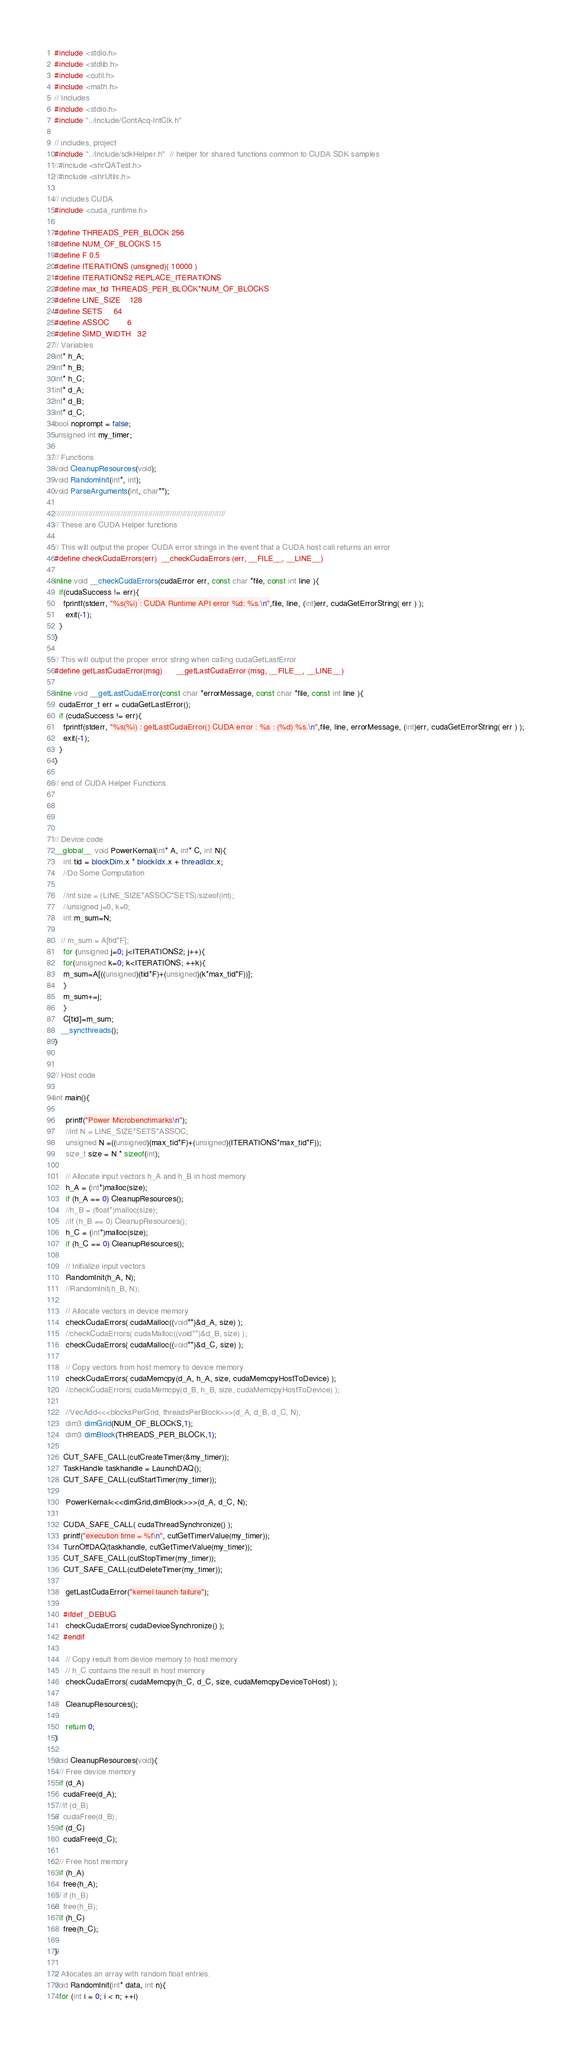Convert code to text. <code><loc_0><loc_0><loc_500><loc_500><_Cuda_>#include <stdio.h>
#include <stdlib.h>
#include <cutil.h>
#include <math.h>
// Includes
#include <stdio.h>
#include "../include/ContAcq-IntClk.h"

// includes, project
#include "../include/sdkHelper.h"  // helper for shared functions common to CUDA SDK samples
//#include <shrQATest.h>
//#include <shrUtils.h>

// includes CUDA
#include <cuda_runtime.h>

#define THREADS_PER_BLOCK 256
#define NUM_OF_BLOCKS 15
#define F 0.5
#define ITERATIONS (unsigned)( 10000 )
#define ITERATIONS2 REPLACE_ITERATIONS
#define max_tid THREADS_PER_BLOCK*NUM_OF_BLOCKS
#define LINE_SIZE 	128
#define SETS		64
#define ASSOC		6
#define SIMD_WIDTH	32
// Variables
int* h_A;
int* h_B;
int* h_C;
int* d_A;
int* d_B;
int* d_C;
bool noprompt = false;
unsigned int my_timer;

// Functions
void CleanupResources(void);
void RandomInit(int*, int);
void ParseArguments(int, char**);

////////////////////////////////////////////////////////////////////////////////
// These are CUDA Helper functions

// This will output the proper CUDA error strings in the event that a CUDA host call returns an error
#define checkCudaErrors(err)  __checkCudaErrors (err, __FILE__, __LINE__)

inline void __checkCudaErrors(cudaError err, const char *file, const int line ){
  if(cudaSuccess != err){
	fprintf(stderr, "%s(%i) : CUDA Runtime API error %d: %s.\n",file, line, (int)err, cudaGetErrorString( err ) );
	 exit(-1);
  }
}

// This will output the proper error string when calling cudaGetLastError
#define getLastCudaError(msg)      __getLastCudaError (msg, __FILE__, __LINE__)

inline void __getLastCudaError(const char *errorMessage, const char *file, const int line ){
  cudaError_t err = cudaGetLastError();
  if (cudaSuccess != err){
	fprintf(stderr, "%s(%i) : getLastCudaError() CUDA error : %s : (%d) %s.\n",file, line, errorMessage, (int)err, cudaGetErrorString( err ) );
	exit(-1);
  }
}

// end of CUDA Helper Functions




// Device code
__global__ void PowerKernal(int* A, int* C, int N){
    int tid = blockDim.x * blockIdx.x + threadIdx.x;
    //Do Some Computation

    //int size = (LINE_SIZE*ASSOC*SETS)/sizeof(int);
    //unsigned j=0, k=0;
    int m_sum=N;

   // m_sum = A[tid*F];
    for (unsigned j=0; j<ITERATIONS2; j++){
    for(unsigned k=0; k<ITERATIONS; ++k){
	m_sum=A[((unsigned)(tid*F)+(unsigned)(k*max_tid*F))];
    }
    m_sum+=j;
    }
    C[tid]=m_sum;
   __syncthreads();
}


// Host code

int main(){

	 printf("Power Microbenchmarks\n");
	 //int N = LINE_SIZE*SETS*ASSOC;
	 unsigned N =((unsigned)(max_tid*F)+(unsigned)(ITERATIONS*max_tid*F));
	 size_t size = N * sizeof(int);

	 // Allocate input vectors h_A and h_B in host memory
	 h_A = (int*)malloc(size);
	 if (h_A == 0) CleanupResources();
	 //h_B = (float*)malloc(size);
	 //if (h_B == 0) CleanupResources();
	 h_C = (int*)malloc(size);
	 if (h_C == 0) CleanupResources();

	 // Initialize input vectors
	 RandomInit(h_A, N);
	 //RandomInit(h_B, N);

	 // Allocate vectors in device memory
	 checkCudaErrors( cudaMalloc((void**)&d_A, size) );
	 //checkCudaErrors( cudaMalloc((void**)&d_B, size) );
	 checkCudaErrors( cudaMalloc((void**)&d_C, size) );

	 // Copy vectors from host memory to device memory
	 checkCudaErrors( cudaMemcpy(d_A, h_A, size, cudaMemcpyHostToDevice) );
	 //checkCudaErrors( cudaMemcpy(d_B, h_B, size, cudaMemcpyHostToDevice) );

	 //VecAdd<<<blocksPerGrid, threadsPerBlock>>>(d_A, d_B, d_C, N);
	 dim3 dimGrid(NUM_OF_BLOCKS,1);
	 dim3 dimBlock(THREADS_PER_BLOCK,1);

	CUT_SAFE_CALL(cutCreateTimer(&my_timer)); 
	TaskHandle taskhandle = LaunchDAQ();
	CUT_SAFE_CALL(cutStartTimer(my_timer)); 

	 PowerKernal<<<dimGrid,dimBlock>>>(d_A, d_C, N);

	CUDA_SAFE_CALL( cudaThreadSynchronize() );
	printf("execution time = %f\n", cutGetTimerValue(my_timer));
	TurnOffDAQ(taskhandle, cutGetTimerValue(my_timer));
	CUT_SAFE_CALL(cutStopTimer(my_timer));
	CUT_SAFE_CALL(cutDeleteTimer(my_timer)); 

	 getLastCudaError("kernel launch failure");

	#ifdef _DEBUG
	 checkCudaErrors( cudaDeviceSynchronize() );
	#endif

	 // Copy result from device memory to host memory
	 // h_C contains the result in host memory
	 checkCudaErrors( cudaMemcpy(h_C, d_C, size, cudaMemcpyDeviceToHost) );

	 CleanupResources();

	 return 0;
}

void CleanupResources(void){
  // Free device memory
  if (d_A)
	cudaFree(d_A);
  //if (d_B)
//	cudaFree(d_B);
  if (d_C)
	cudaFree(d_C);

  // Free host memory
  if (h_A)
	free(h_A);
 // if (h_B)
//	free(h_B);
  if (h_C)
	free(h_C);

}

// Allocates an array with random float entries.
void RandomInit(int* data, int n){
  for (int i = 0; i < n; ++i)</code> 